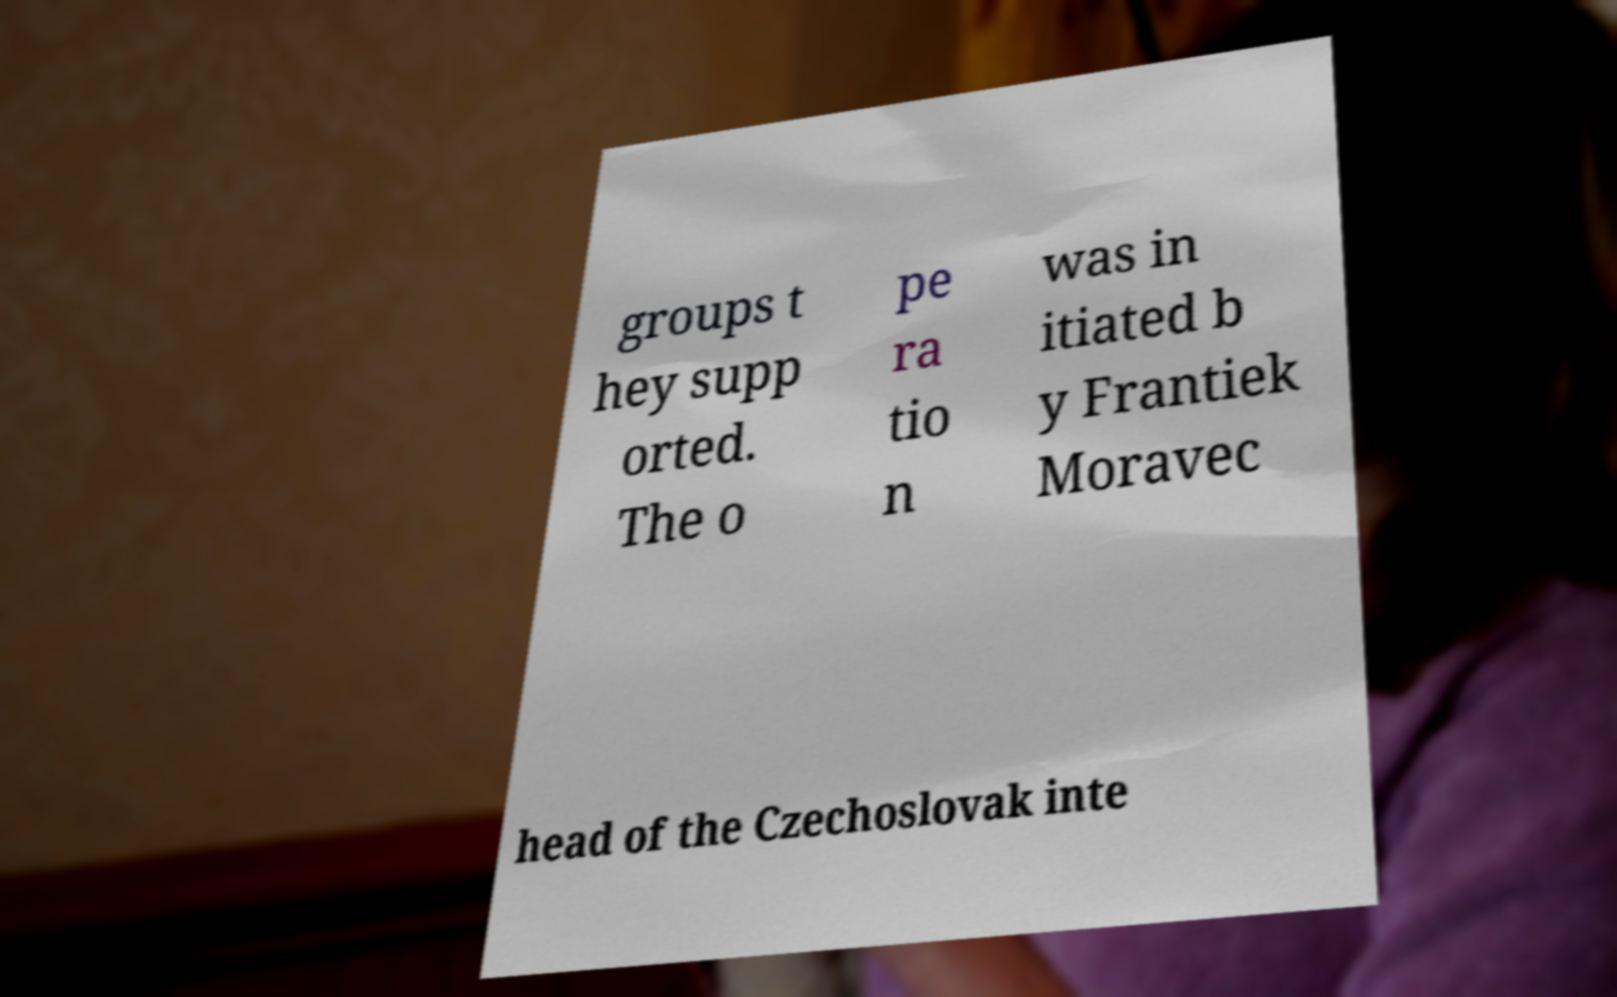Please identify and transcribe the text found in this image. groups t hey supp orted. The o pe ra tio n was in itiated b y Frantiek Moravec head of the Czechoslovak inte 